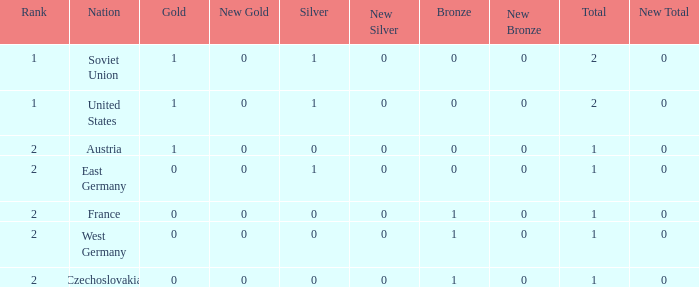Could you parse the entire table? {'header': ['Rank', 'Nation', 'Gold', 'New Gold', 'Silver', 'New Silver', 'Bronze', 'New Bronze', 'Total', 'New Total'], 'rows': [['1', 'Soviet Union', '1', '0', '1', '0', '0', '0', '2', '0'], ['1', 'United States', '1', '0', '1', '0', '0', '0', '2', '0'], ['2', 'Austria', '1', '0', '0', '0', '0', '0', '1', '0'], ['2', 'East Germany', '0', '0', '1', '0', '0', '0', '1', '0'], ['2', 'France', '0', '0', '0', '0', '1', '0', '1', '0'], ['2', 'West Germany', '0', '0', '0', '0', '1', '0', '1', '0'], ['2', 'Czechoslovakia', '0', '0', '0', '0', '1', '0', '1', '0']]} What is the highest rank of Austria, which had less than 0 silvers? None. 